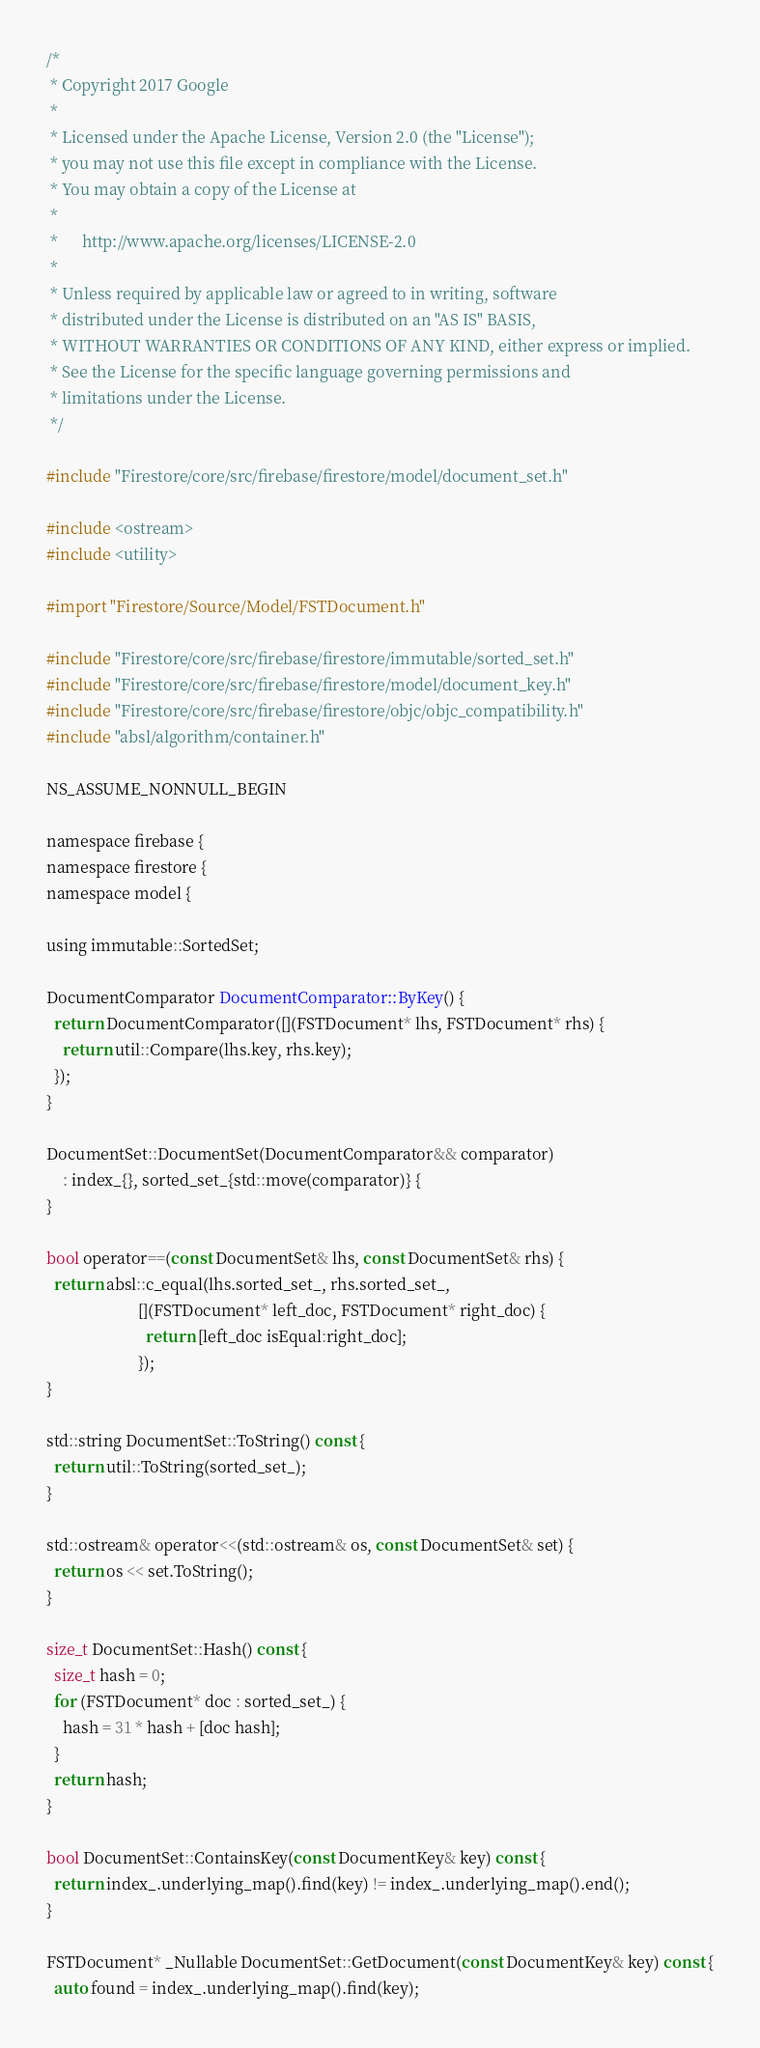<code> <loc_0><loc_0><loc_500><loc_500><_ObjectiveC_>/*
 * Copyright 2017 Google
 *
 * Licensed under the Apache License, Version 2.0 (the "License");
 * you may not use this file except in compliance with the License.
 * You may obtain a copy of the License at
 *
 *      http://www.apache.org/licenses/LICENSE-2.0
 *
 * Unless required by applicable law or agreed to in writing, software
 * distributed under the License is distributed on an "AS IS" BASIS,
 * WITHOUT WARRANTIES OR CONDITIONS OF ANY KIND, either express or implied.
 * See the License for the specific language governing permissions and
 * limitations under the License.
 */

#include "Firestore/core/src/firebase/firestore/model/document_set.h"

#include <ostream>
#include <utility>

#import "Firestore/Source/Model/FSTDocument.h"

#include "Firestore/core/src/firebase/firestore/immutable/sorted_set.h"
#include "Firestore/core/src/firebase/firestore/model/document_key.h"
#include "Firestore/core/src/firebase/firestore/objc/objc_compatibility.h"
#include "absl/algorithm/container.h"

NS_ASSUME_NONNULL_BEGIN

namespace firebase {
namespace firestore {
namespace model {

using immutable::SortedSet;

DocumentComparator DocumentComparator::ByKey() {
  return DocumentComparator([](FSTDocument* lhs, FSTDocument* rhs) {
    return util::Compare(lhs.key, rhs.key);
  });
}

DocumentSet::DocumentSet(DocumentComparator&& comparator)
    : index_{}, sorted_set_{std::move(comparator)} {
}

bool operator==(const DocumentSet& lhs, const DocumentSet& rhs) {
  return absl::c_equal(lhs.sorted_set_, rhs.sorted_set_,
                       [](FSTDocument* left_doc, FSTDocument* right_doc) {
                         return [left_doc isEqual:right_doc];
                       });
}

std::string DocumentSet::ToString() const {
  return util::ToString(sorted_set_);
}

std::ostream& operator<<(std::ostream& os, const DocumentSet& set) {
  return os << set.ToString();
}

size_t DocumentSet::Hash() const {
  size_t hash = 0;
  for (FSTDocument* doc : sorted_set_) {
    hash = 31 * hash + [doc hash];
  }
  return hash;
}

bool DocumentSet::ContainsKey(const DocumentKey& key) const {
  return index_.underlying_map().find(key) != index_.underlying_map().end();
}

FSTDocument* _Nullable DocumentSet::GetDocument(const DocumentKey& key) const {
  auto found = index_.underlying_map().find(key);</code> 